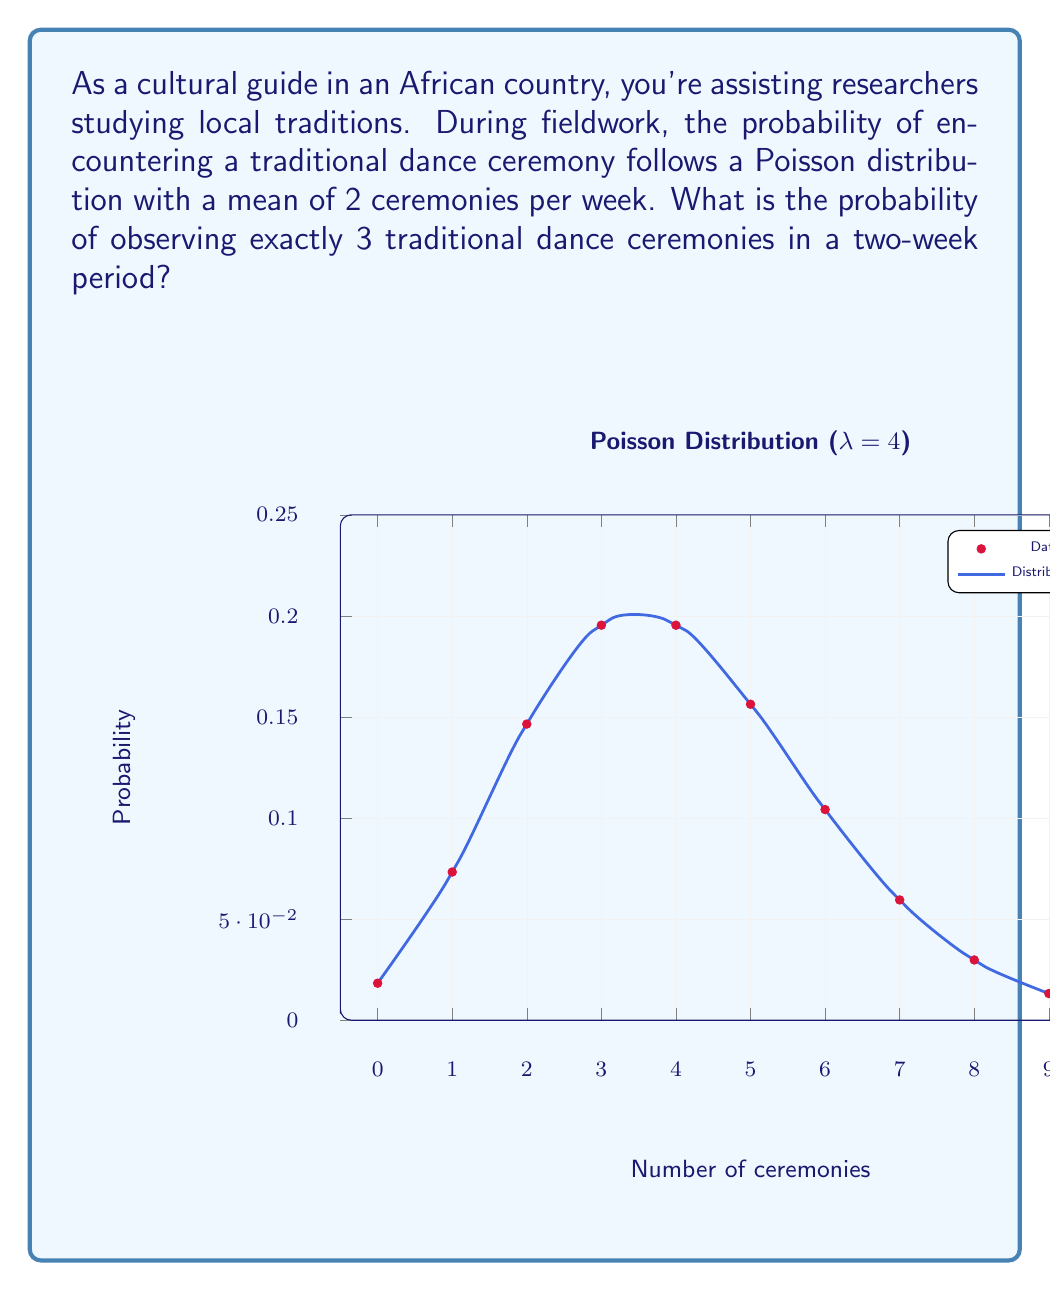Give your solution to this math problem. To solve this problem, we'll use the Poisson distribution formula:

$$P(X = k) = \frac{e^{-\lambda} \lambda^k}{k!}$$

Where:
$\lambda$ = mean number of events in the given time period
$k$ = number of events we're calculating the probability for
$e$ = Euler's number (approximately 2.71828)

Steps:
1) First, calculate $\lambda$ for a two-week period:
   $\lambda = 2 \text{ ceremonies/week} \times 2 \text{ weeks} = 4 \text{ ceremonies}$

2) Now, we want the probability of exactly 3 ceremonies ($k = 3$) when $\lambda = 4$:

   $$P(X = 3) = \frac{e^{-4} 4^3}{3!}$$

3) Calculate:
   $$P(X = 3) = \frac{e^{-4} \times 64}{6}$$

4) Using a calculator or computer:
   $$P(X = 3) \approx 0.1954$$

5) Convert to a percentage:
   $0.1954 \times 100\% = 19.54\%$

Thus, the probability of observing exactly 3 traditional dance ceremonies in a two-week period is approximately 19.54%.
Answer: 19.54% 